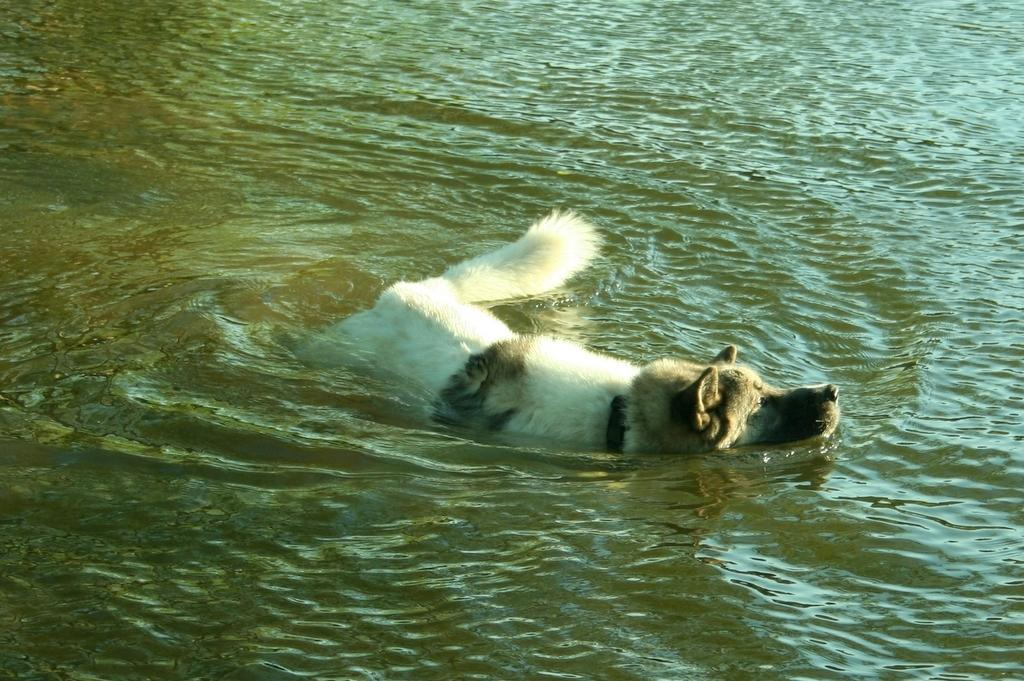What is the main subject of the image? There is a dog in the center of the image. Where is the dog located in the image? The dog is in the water. What else can be seen in the image besides the dog? There is water visible in the image. What type of furniture can be seen in the image? There is no furniture present in the image; it features a dog in the water. 